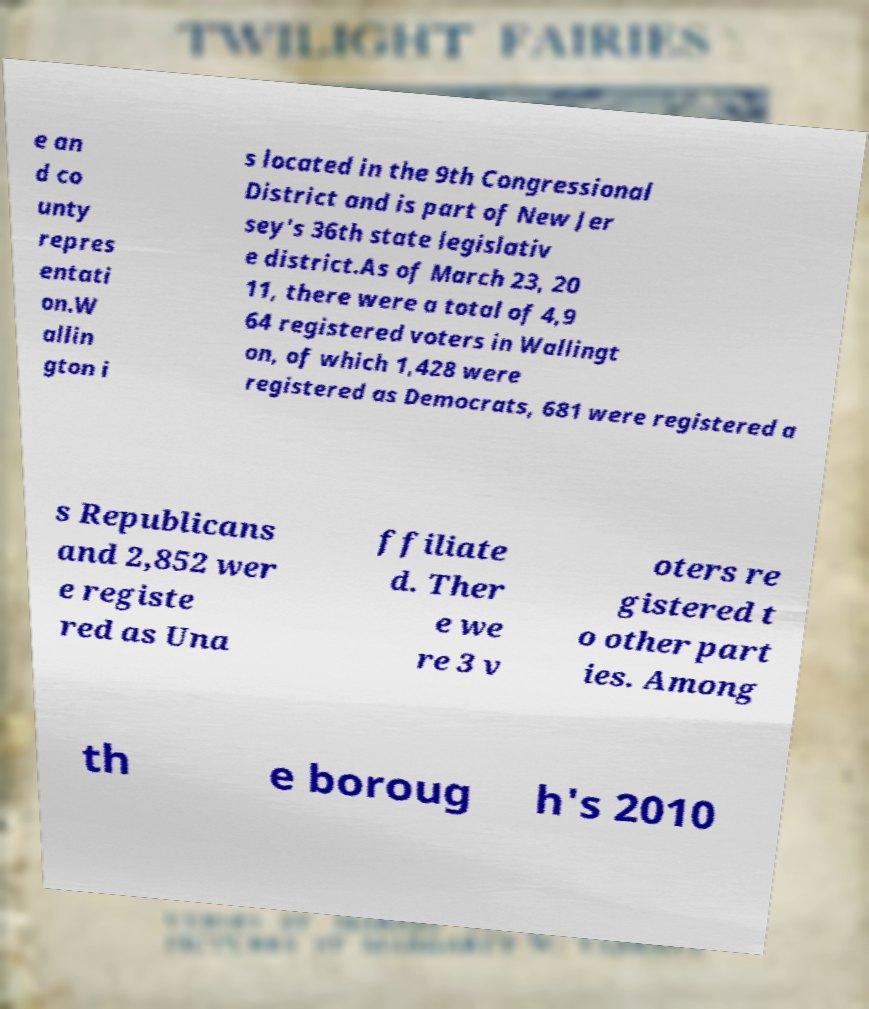Please read and relay the text visible in this image. What does it say? e an d co unty repres entati on.W allin gton i s located in the 9th Congressional District and is part of New Jer sey's 36th state legislativ e district.As of March 23, 20 11, there were a total of 4,9 64 registered voters in Wallingt on, of which 1,428 were registered as Democrats, 681 were registered a s Republicans and 2,852 wer e registe red as Una ffiliate d. Ther e we re 3 v oters re gistered t o other part ies. Among th e boroug h's 2010 